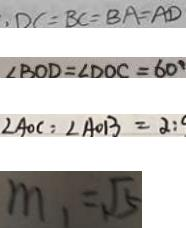<formula> <loc_0><loc_0><loc_500><loc_500>, D C = B C = B A = A D 
 \angle B O D = \angle D O C = 6 0 ^ { \circ } 
 \angle A O C = \angle A O B = 2 : 
 m _ { 1 } = \sqrt { 5 }</formula> 